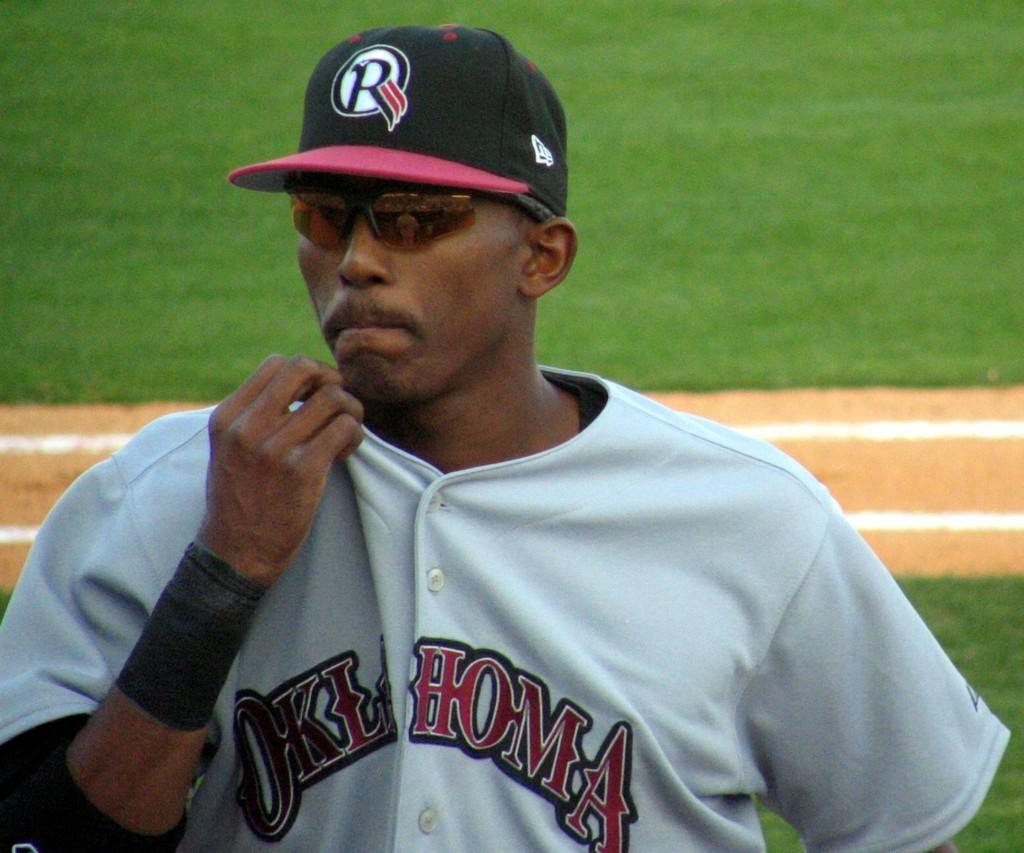<image>
Render a clear and concise summary of the photo. Baseball player wearing a jersey which says Oklahoma standing on the field. 